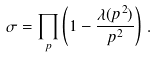<formula> <loc_0><loc_0><loc_500><loc_500>\sigma = \prod _ { p } \left ( 1 - \frac { \lambda ( p ^ { 2 } ) } { p ^ { 2 } } \right ) \, .</formula> 